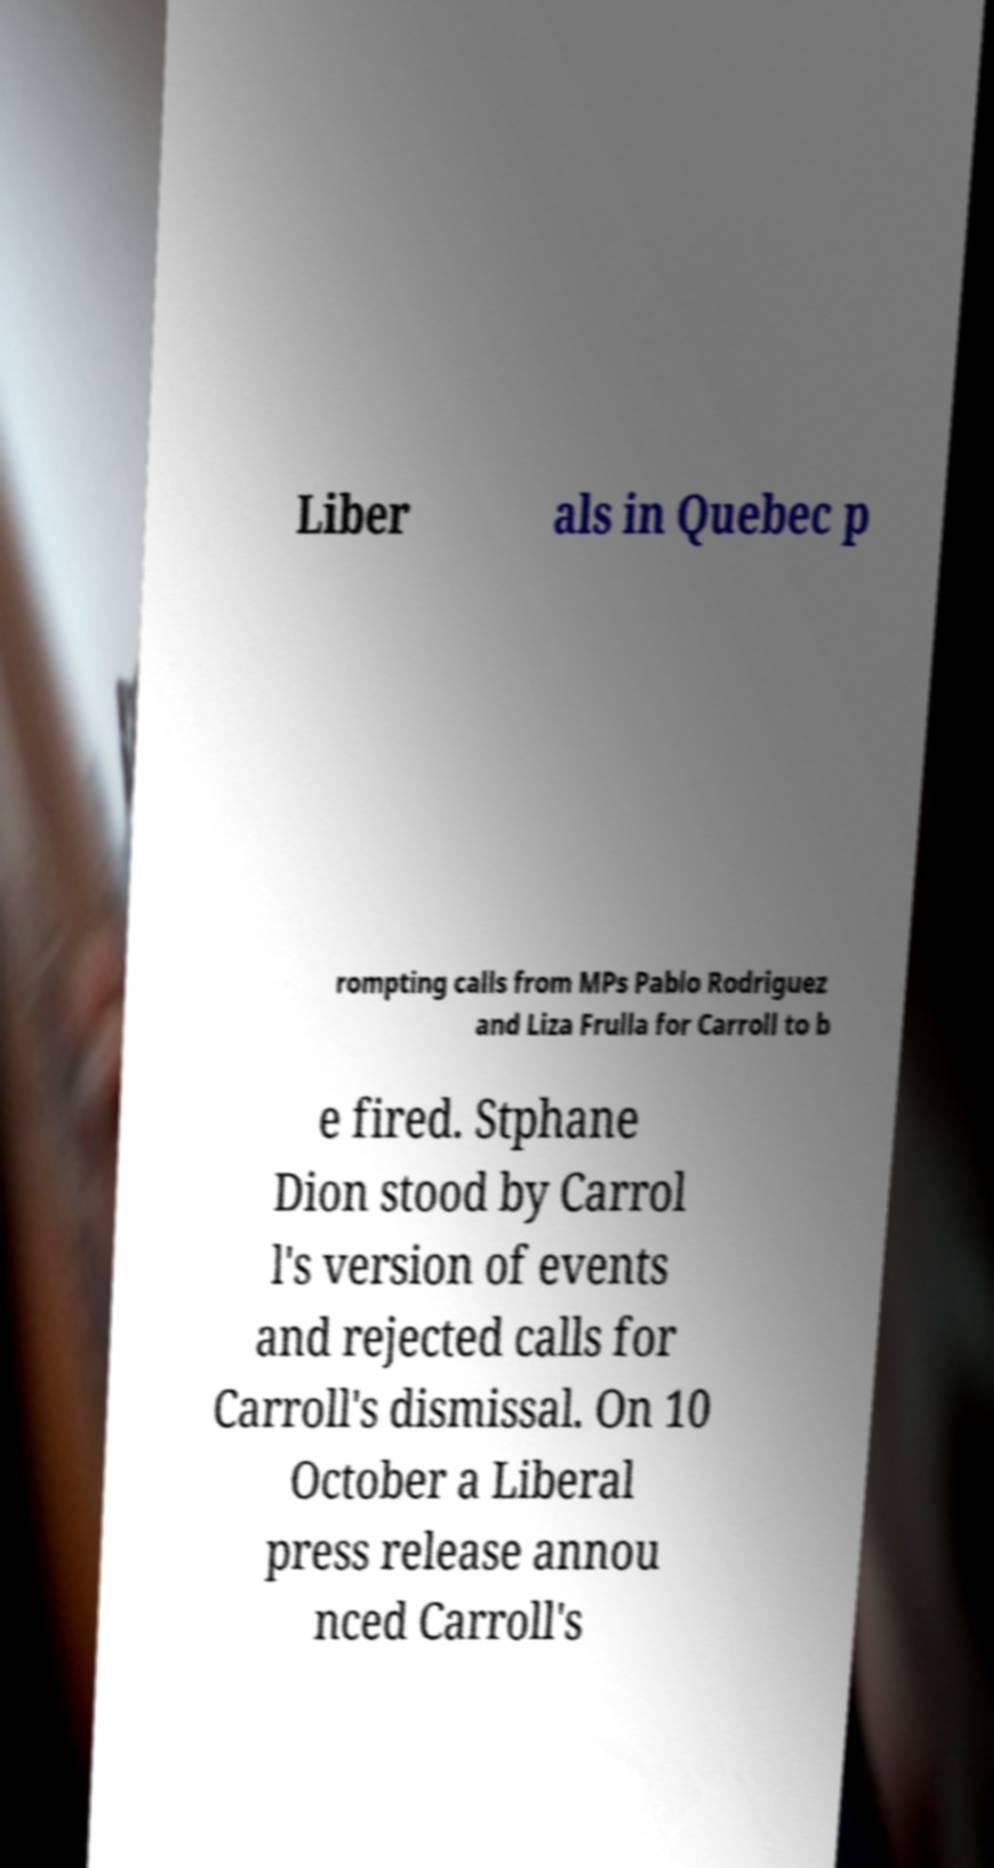Can you read and provide the text displayed in the image?This photo seems to have some interesting text. Can you extract and type it out for me? Liber als in Quebec p rompting calls from MPs Pablo Rodriguez and Liza Frulla for Carroll to b e fired. Stphane Dion stood by Carrol l's version of events and rejected calls for Carroll's dismissal. On 10 October a Liberal press release annou nced Carroll's 